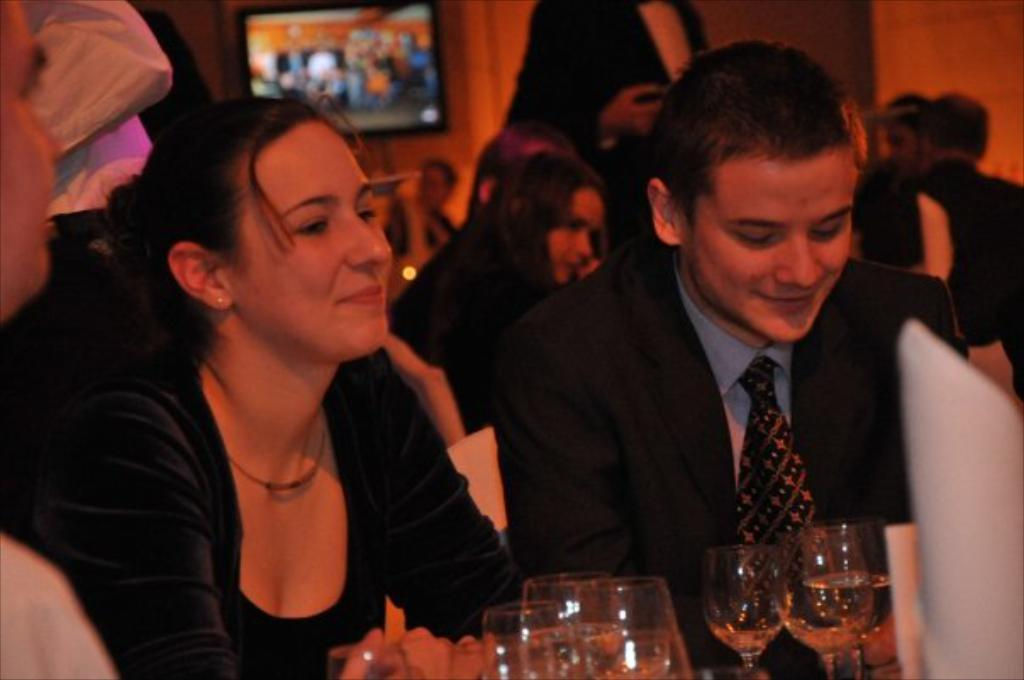What are the people in the image doing? The people in the image are sitting on chairs. What is in front of the chairs? There is a table in front of the chairs. What can be seen on the table? There are glasses on the table. What is visible in the background of the image? There is a wall in the background of the image. What is on the wall? There is a TV on the wall. Can you see any matches on the table in the image? There are no matches visible on the table in the image. 